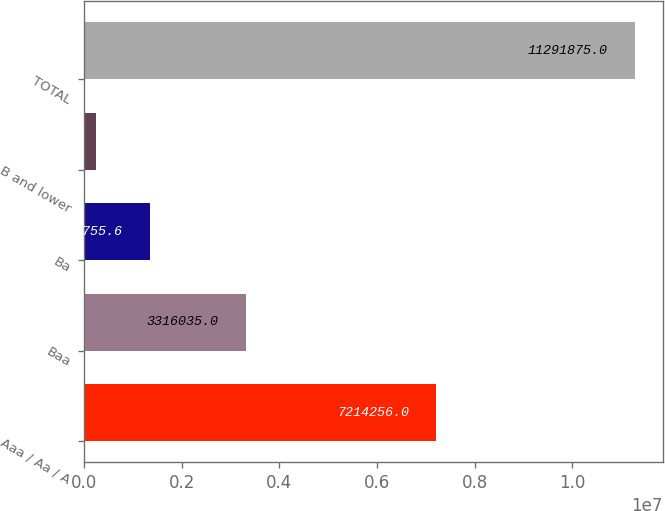<chart> <loc_0><loc_0><loc_500><loc_500><bar_chart><fcel>Aaa / Aa / A<fcel>Baa<fcel>Ba<fcel>B and lower<fcel>TOTAL<nl><fcel>7.21426e+06<fcel>3.31604e+06<fcel>1.34376e+06<fcel>238409<fcel>1.12919e+07<nl></chart> 